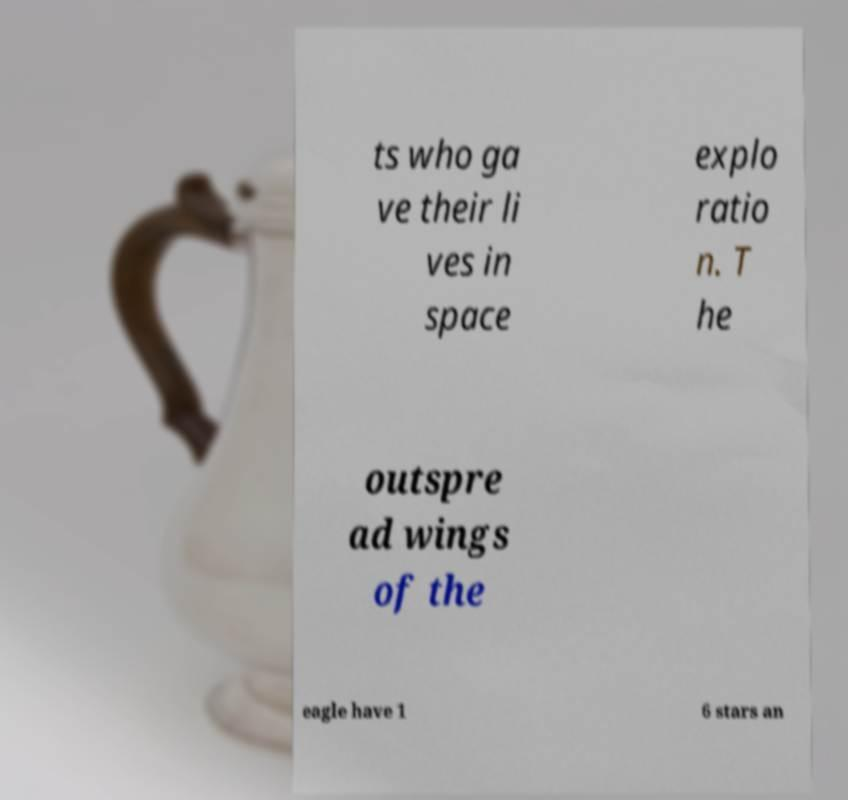Could you extract and type out the text from this image? ts who ga ve their li ves in space explo ratio n. T he outspre ad wings of the eagle have 1 6 stars an 